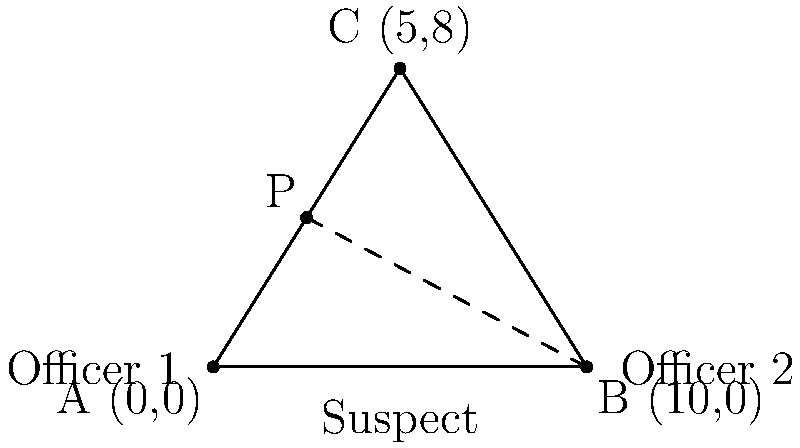Two police officers are in pursuit of a suspect. Officer 1 starts at point A (0,0) and follows the path represented by the equation $y = 1.6x$. Officer 2 starts at point B (10,0) and follows the path represented by the equation $y = -1.6x + 16$. The suspect is initially at point C (5,8). At what point (x,y) will the pursuit paths of the two officers intersect, potentially allowing them to coordinate their efforts to apprehend the suspect? To find the intersection point of the two pursuit paths, we need to solve the system of equations:

1) Officer 1's path: $y = 1.6x$
2) Officer 2's path: $y = -1.6x + 16$

Step 1: Set the equations equal to each other
$1.6x = -1.6x + 16$

Step 2: Solve for x
$3.2x = 16$
$x = 5$

Step 3: Substitute x = 5 into either equation to find y
Using Officer 1's equation: $y = 1.6(5) = 8$

Step 4: Verify the solution
The point (5,8) satisfies both equations:
Officer 1: $8 = 1.6(5)$
Officer 2: $8 = -1.6(5) + 16$

Therefore, the pursuit paths intersect at the point (5,8), which coincidentally is also the initial position of the suspect (point C). This intersection point allows the officers to potentially coordinate their efforts and apprehend the suspect more effectively.
Answer: (5,8) 